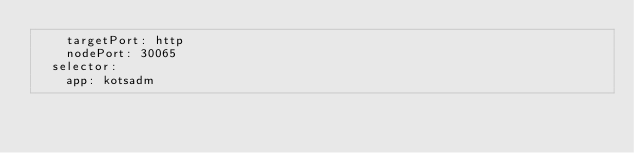<code> <loc_0><loc_0><loc_500><loc_500><_YAML_>    targetPort: http
    nodePort: 30065
  selector:
    app: kotsadm
</code> 